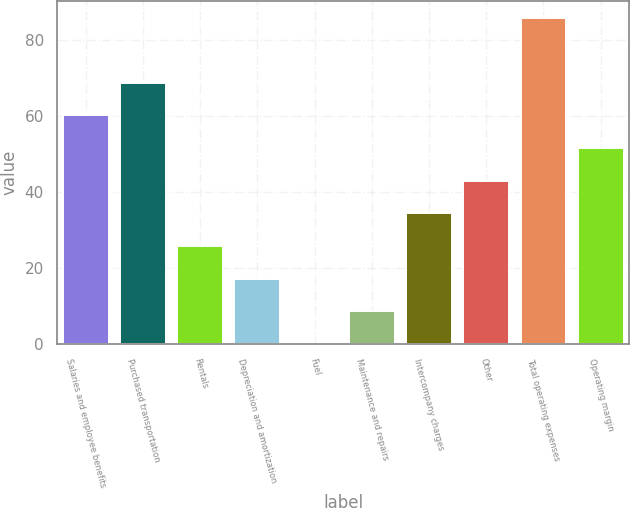Convert chart. <chart><loc_0><loc_0><loc_500><loc_500><bar_chart><fcel>Salaries and employee benefits<fcel>Purchased transportation<fcel>Rentals<fcel>Depreciation and amortization<fcel>Fuel<fcel>Maintenance and repairs<fcel>Intercompany charges<fcel>Other<fcel>Total operating expenses<fcel>Operating margin<nl><fcel>60.09<fcel>68.66<fcel>25.81<fcel>17.24<fcel>0.1<fcel>8.67<fcel>34.38<fcel>42.95<fcel>85.8<fcel>51.52<nl></chart> 